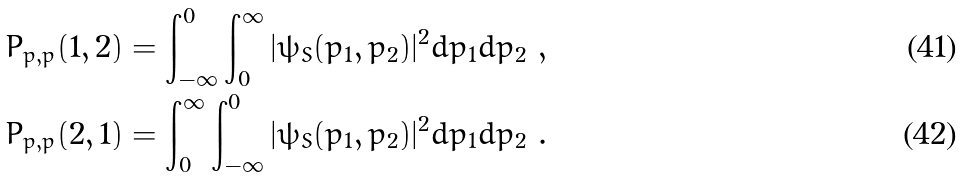Convert formula to latex. <formula><loc_0><loc_0><loc_500><loc_500>P _ { p , p } ( 1 , 2 ) & = \int _ { - \infty } ^ { 0 } \int _ { 0 } ^ { \infty } | \psi _ { S } ( p _ { 1 } , p _ { 2 } ) | ^ { 2 } d p _ { 1 } d p _ { 2 } \ , \\ P _ { p , p } ( 2 , 1 ) & = \int _ { 0 } ^ { \infty } \int _ { - \infty } ^ { 0 } | \psi _ { S } ( p _ { 1 } , p _ { 2 } ) | ^ { 2 } d p _ { 1 } d p _ { 2 } \ .</formula> 